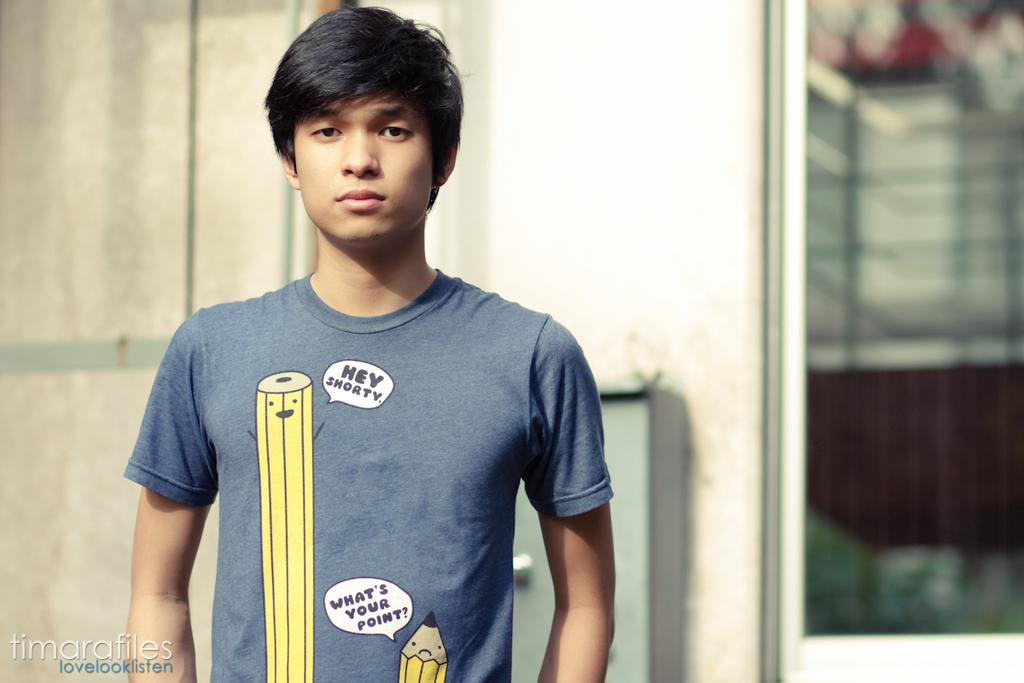<image>
Give a short and clear explanation of the subsequent image. A boy is wearing a shirt that says Hey Shorty. 